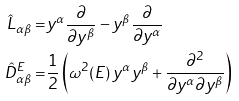Convert formula to latex. <formula><loc_0><loc_0><loc_500><loc_500>\hat { L } _ { \alpha \beta } = & y ^ { \alpha } \frac { \partial } { \partial y ^ { \beta } } - y ^ { \beta } \frac { \partial } { \partial y ^ { \alpha } } \\ \hat { D } ^ { E } _ { \alpha \beta } = & \frac { 1 } { 2 } \left ( \omega ^ { 2 } ( E ) \, y ^ { \alpha } y ^ { \beta } + \frac { \partial ^ { 2 } } { \partial y ^ { \alpha } \partial y ^ { \beta } } \right )</formula> 